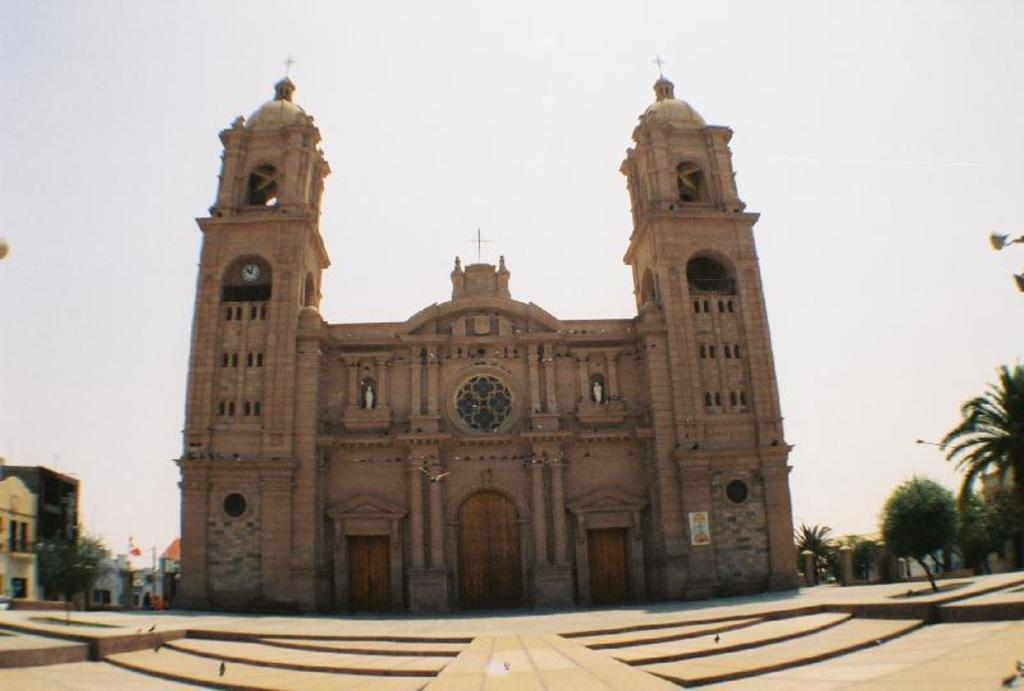What type of surface is visible in the image? There is a pavement in the image. What can be seen in the background of the image? There is a monument, buildings, trees, and the sky visible in the background of the image. Where is the guitar placed in the image? There is no guitar present in the image. What shape is the throne in the image? There is no throne present in the image. 